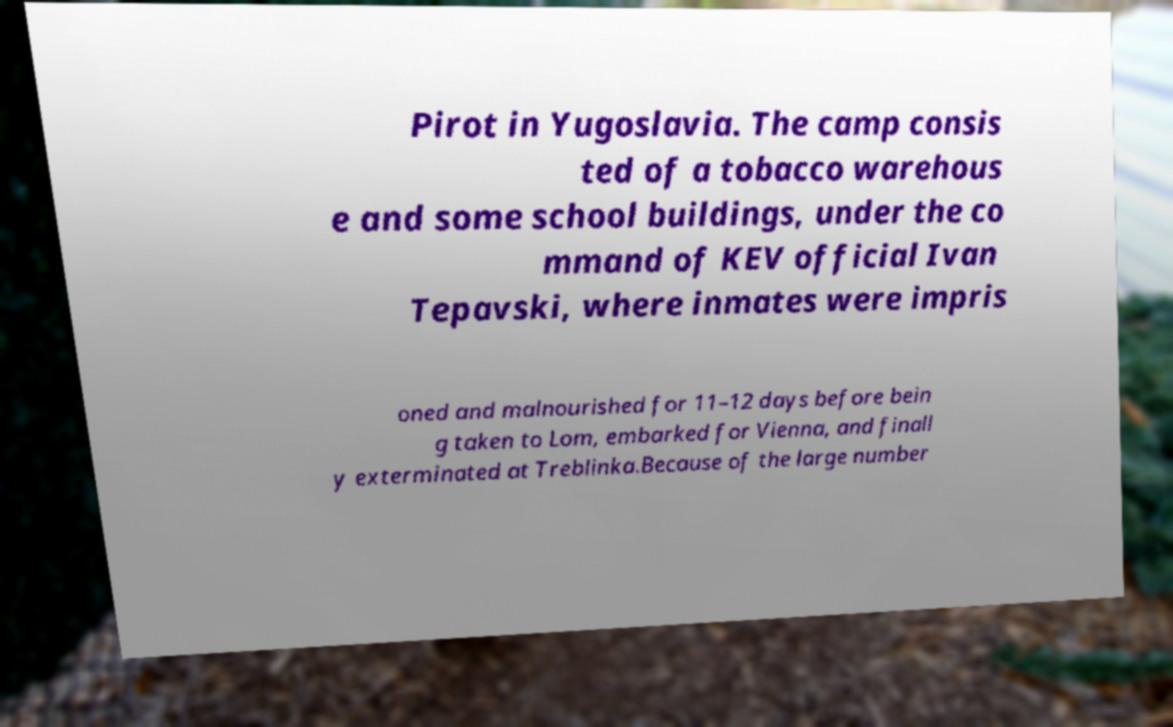For documentation purposes, I need the text within this image transcribed. Could you provide that? Pirot in Yugoslavia. The camp consis ted of a tobacco warehous e and some school buildings, under the co mmand of KEV official Ivan Tepavski, where inmates were impris oned and malnourished for 11–12 days before bein g taken to Lom, embarked for Vienna, and finall y exterminated at Treblinka.Because of the large number 